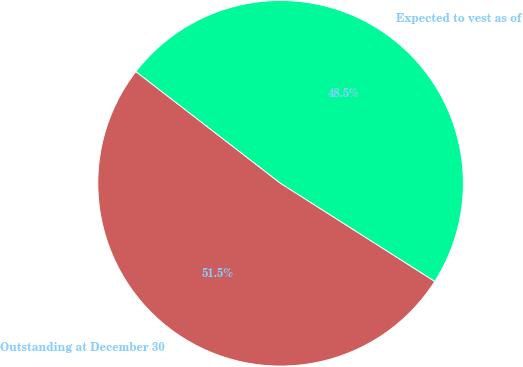<chart> <loc_0><loc_0><loc_500><loc_500><pie_chart><fcel>Outstanding at December 30<fcel>Expected to vest as of<nl><fcel>51.45%<fcel>48.55%<nl></chart> 